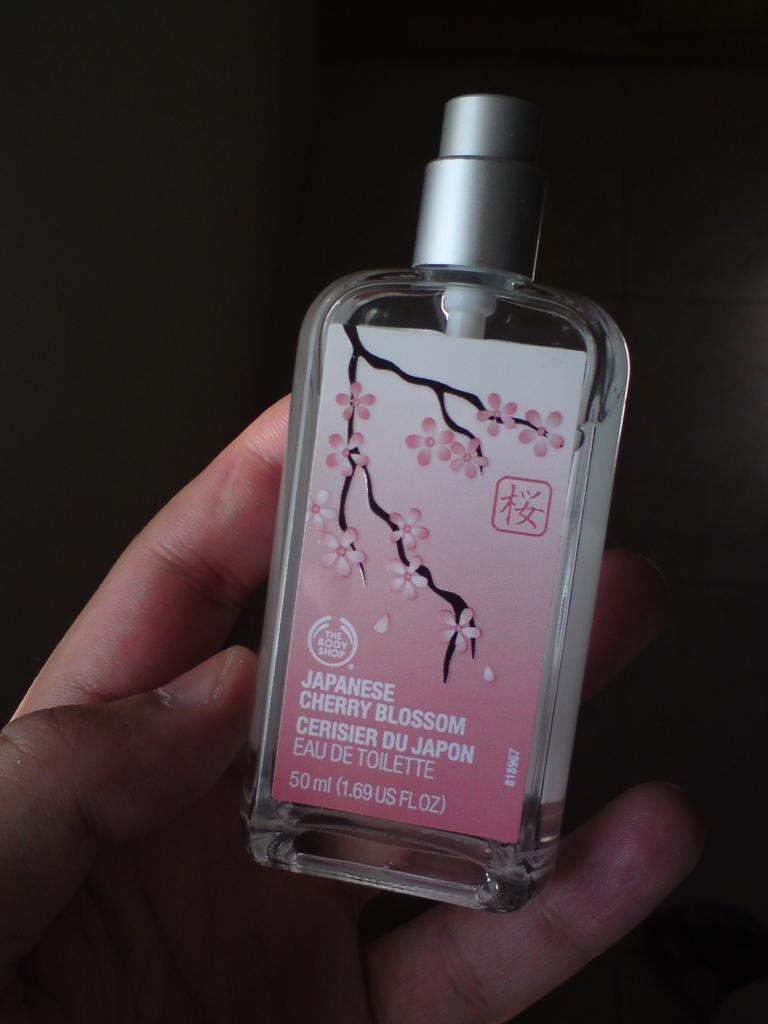<image>
Create a compact narrative representing the image presented. a hand holding a Japanese Cherry Blossom perfume 